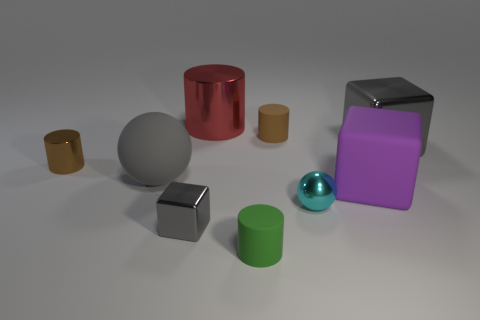Add 1 large red cylinders. How many objects exist? 10 Subtract all blocks. How many objects are left? 6 Subtract all small green balls. Subtract all tiny cylinders. How many objects are left? 6 Add 4 metal cubes. How many metal cubes are left? 6 Add 2 tiny cyan spheres. How many tiny cyan spheres exist? 3 Subtract 0 gray cylinders. How many objects are left? 9 